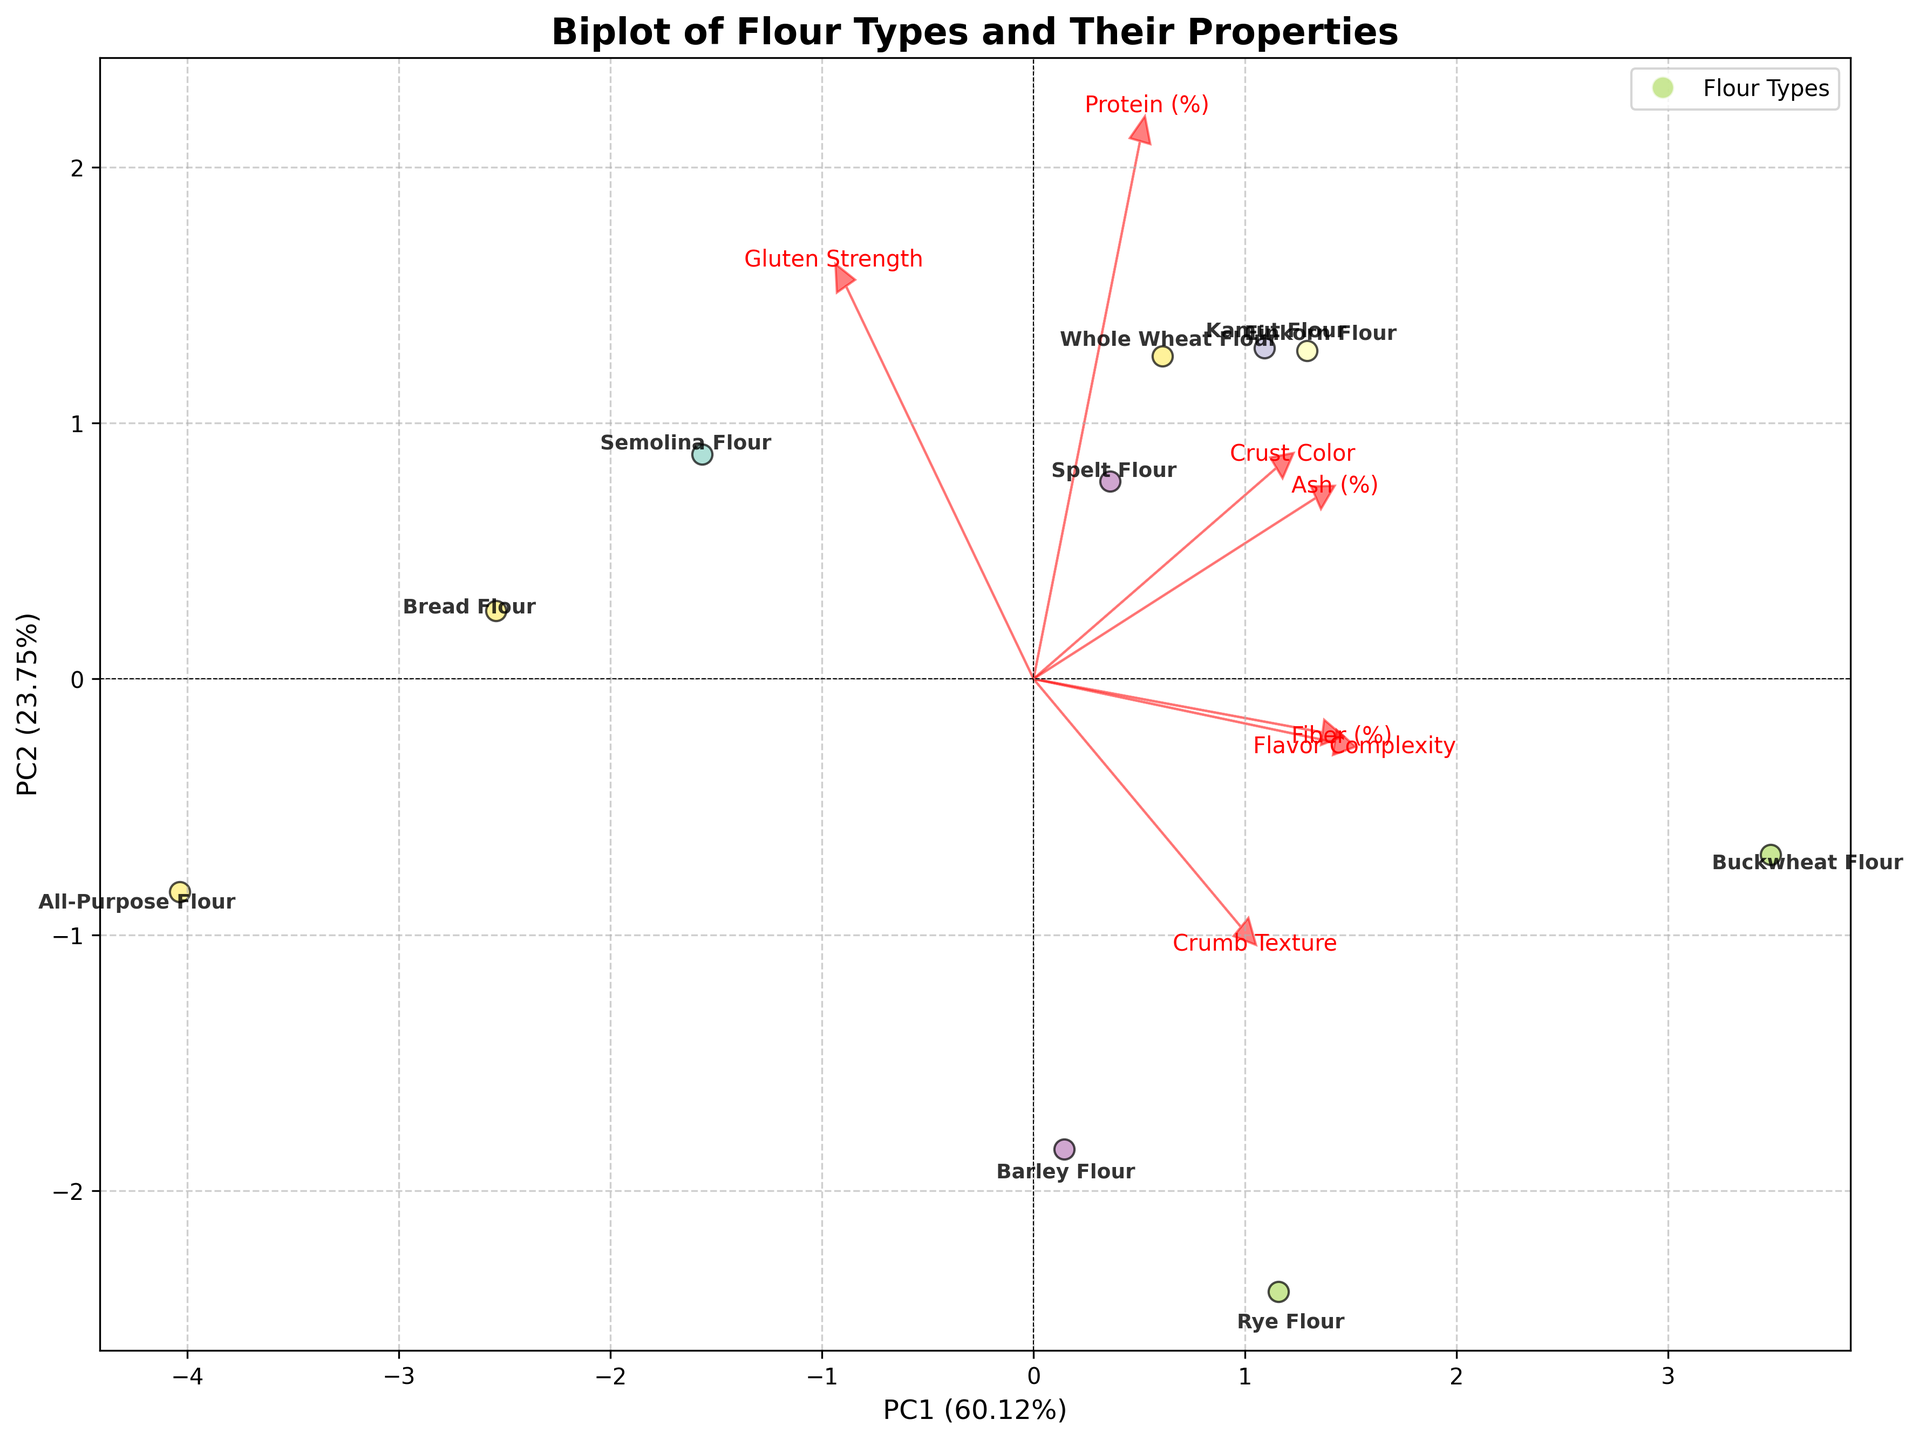What's the main aim of the biplot of flour types? The biplot illustrates the relationship between various flour types and their nutritional and baking properties by projecting them onto principal components derived from a PCA analysis. This allows for visual comparison of flour types based on key features and interpretation of how features influence the positioning of the samples.
Answer: Compare flour types based on properties What do the arrows represent in the biplot? The arrows represent the direction and magnitude of each feature's contribution to the principal components. The longer the arrow, the more significant its contribution.
Answer: Feature contributions Which flour type is most closely associated with high protein and fiber content? Einkorn flour, as its position is farthest in the direction of the arrows representing "Protein (%)" and "Fiber (%)".
Answer: Einkorn flour Which feature has the most significant influence on the first principal component (PC1)? The feature with the longest arrow pointing in the direction of PC1 has the most significant influence. In this case, "Protein (%)" has a substantial length in the PC1 direction.
Answer: Protein (%) Is there any flour type that stands out for its high "Flavor Complexity"? Yes, Buckwheat Flour, as it is positioned further in the direction pointing towards "Flavor Complexity".
Answer: Buckwheat Flour How does All-Purpose Flour compare with Bread Flour in terms of "Crumb Texture" and "Flavor Complexity"? Bread Flour appears to have higher values for both "Crumb Texture" and "Flavor Complexity" compared to All-Purpose Flour, as it is positioned further in the direction of arrows representing these features.
Answer: Bread Flour has higher values Which two flour types have similar positions on the biplot indicating they have similar overall properties? Spelt Flour and Kamut Flour closely overlap on the biplot, suggesting they have similar nutritional and baking properties.
Answer: Spelt Flour and Kamut Flour Given their position, which flour type would likely result in the softest crumb texture? Rye Flour, as it is closely positioned along the direction associated with higher "Crumb Texture" values.
Answer: Rye Flour How does "Gluten Strength" relate to PC2? "Gluten Strength" has a shorter arrow in the direction of PC2, suggesting it has less influence on this component compared to other features.
Answer: Less influence Why might one choose Kamut Flour over Semolina Flour for a highly flavorful bread? Kamut Flour is positioned further in the direction of the "Flavor Complexity" arrow compared to Semolina Flour, indicating it has higher flavor complexity.
Answer: Higher flavor complexity 